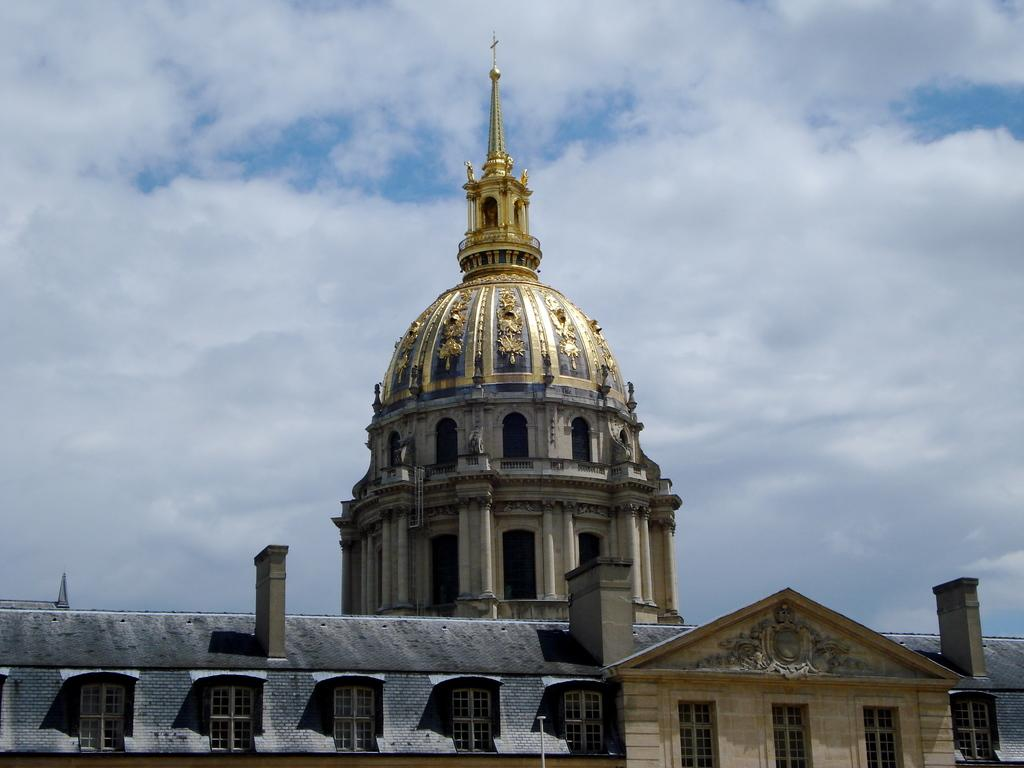What type of architecture is featured in the image? The image contains ancient architecture. What can be seen in the background of the image? There is sky visible in the background of the image. What is the weather like in the image? The presence of clouds in the sky suggests that it is not a completely clear day. How many bikes are parked near the ancient architecture in the image? There are no bikes present in the image; it features ancient architecture and a sky with clouds. 